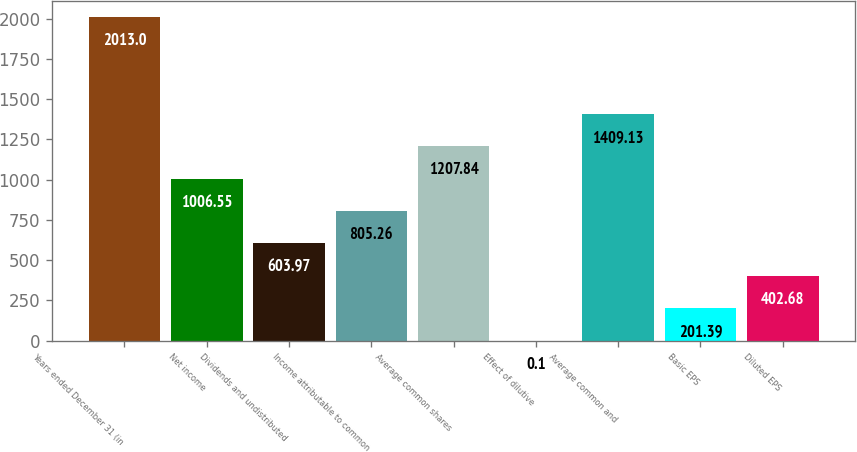Convert chart. <chart><loc_0><loc_0><loc_500><loc_500><bar_chart><fcel>Years ended December 31 (in<fcel>Net income<fcel>Dividends and undistributed<fcel>Income attributable to common<fcel>Average common shares<fcel>Effect of dilutive<fcel>Average common and<fcel>Basic EPS<fcel>Diluted EPS<nl><fcel>2013<fcel>1006.55<fcel>603.97<fcel>805.26<fcel>1207.84<fcel>0.1<fcel>1409.13<fcel>201.39<fcel>402.68<nl></chart> 